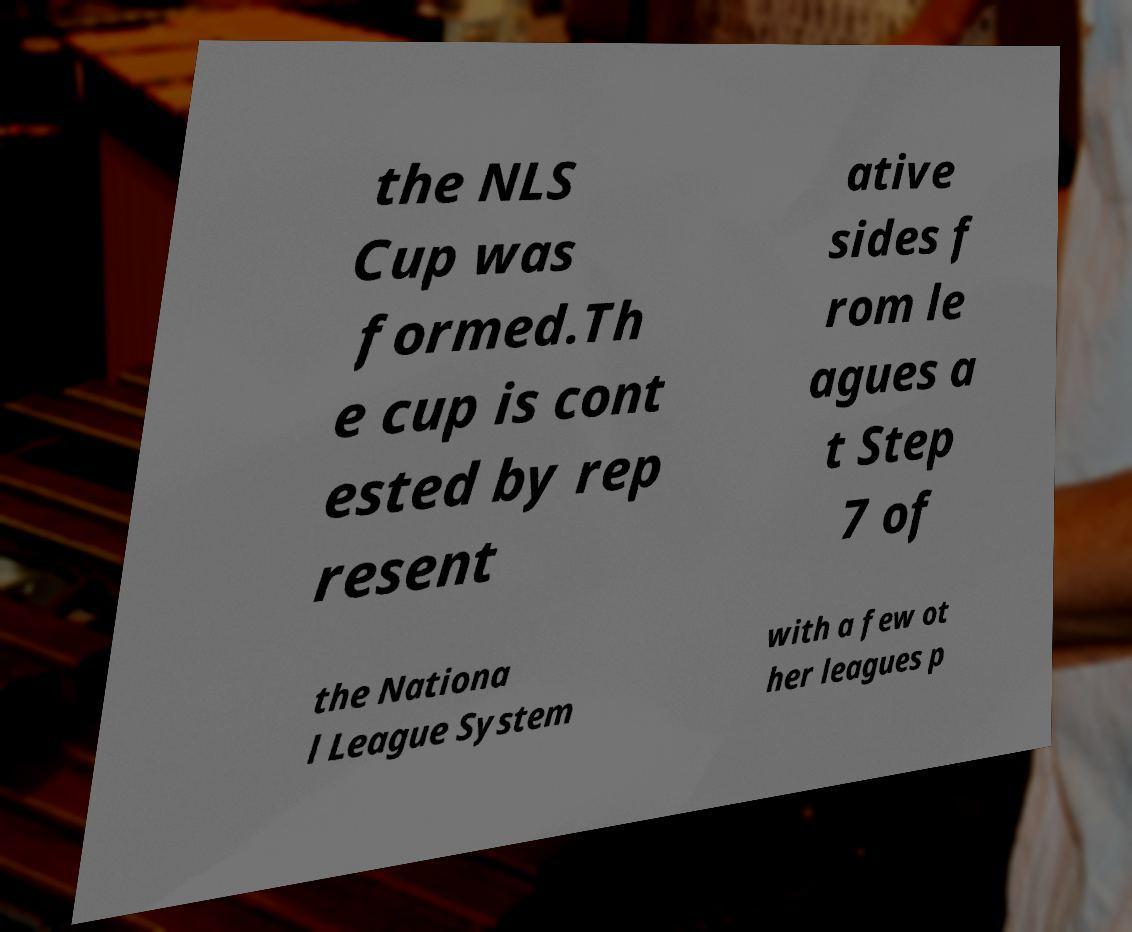There's text embedded in this image that I need extracted. Can you transcribe it verbatim? the NLS Cup was formed.Th e cup is cont ested by rep resent ative sides f rom le agues a t Step 7 of the Nationa l League System with a few ot her leagues p 